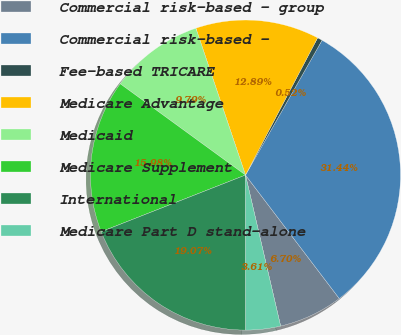Convert chart. <chart><loc_0><loc_0><loc_500><loc_500><pie_chart><fcel>Commercial risk-based - group<fcel>Commercial risk-based -<fcel>Fee-based TRICARE<fcel>Medicare Advantage<fcel>Medicaid<fcel>Medicare Supplement<fcel>International<fcel>Medicare Part D stand-alone<nl><fcel>6.7%<fcel>31.44%<fcel>0.52%<fcel>12.89%<fcel>9.79%<fcel>15.98%<fcel>19.07%<fcel>3.61%<nl></chart> 